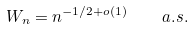<formula> <loc_0><loc_0><loc_500><loc_500>W _ { n } = n ^ { - 1 / 2 + o ( 1 ) } \quad a . s .</formula> 